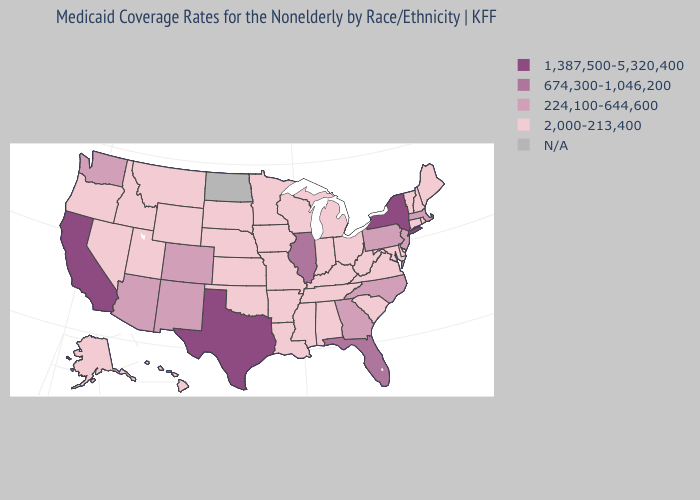What is the value of Texas?
Quick response, please. 1,387,500-5,320,400. What is the lowest value in the USA?
Short answer required. 2,000-213,400. Does the first symbol in the legend represent the smallest category?
Quick response, please. No. Among the states that border Nevada , which have the highest value?
Give a very brief answer. California. What is the value of Montana?
Concise answer only. 2,000-213,400. What is the value of Washington?
Short answer required. 224,100-644,600. Among the states that border Washington , which have the lowest value?
Keep it brief. Idaho, Oregon. What is the value of Pennsylvania?
Quick response, please. 224,100-644,600. What is the value of Michigan?
Keep it brief. 2,000-213,400. Does Rhode Island have the lowest value in the Northeast?
Be succinct. Yes. 